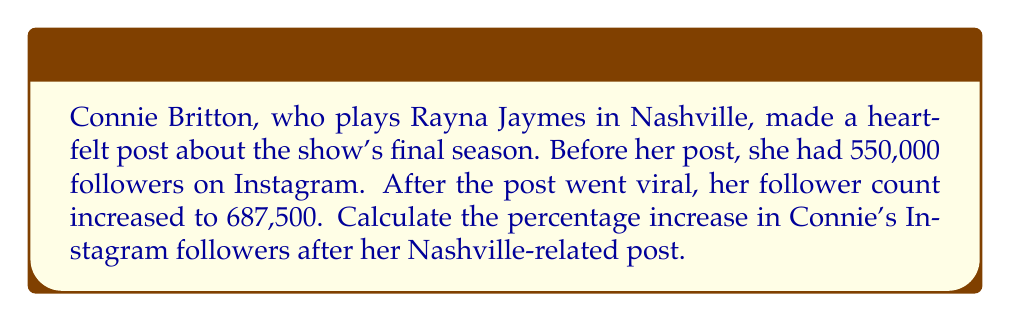Can you answer this question? To calculate the percentage increase, we need to follow these steps:

1. Calculate the absolute increase in followers:
   $\text{Increase} = \text{New followers} - \text{Original followers}$
   $\text{Increase} = 687,500 - 550,000 = 137,500$

2. Calculate the percentage increase using the formula:
   $$\text{Percentage increase} = \frac{\text{Increase}}{\text{Original value}} \times 100\%$$

3. Substitute the values into the formula:
   $$\text{Percentage increase} = \frac{137,500}{550,000} \times 100\%$$

4. Simplify the fraction:
   $$\text{Percentage increase} = 0.25 \times 100\%$$

5. Calculate the final percentage:
   $$\text{Percentage increase} = 25\%$$

Therefore, Connie Britton's Instagram followers increased by 25% after her Nashville-related post.
Answer: 25% 